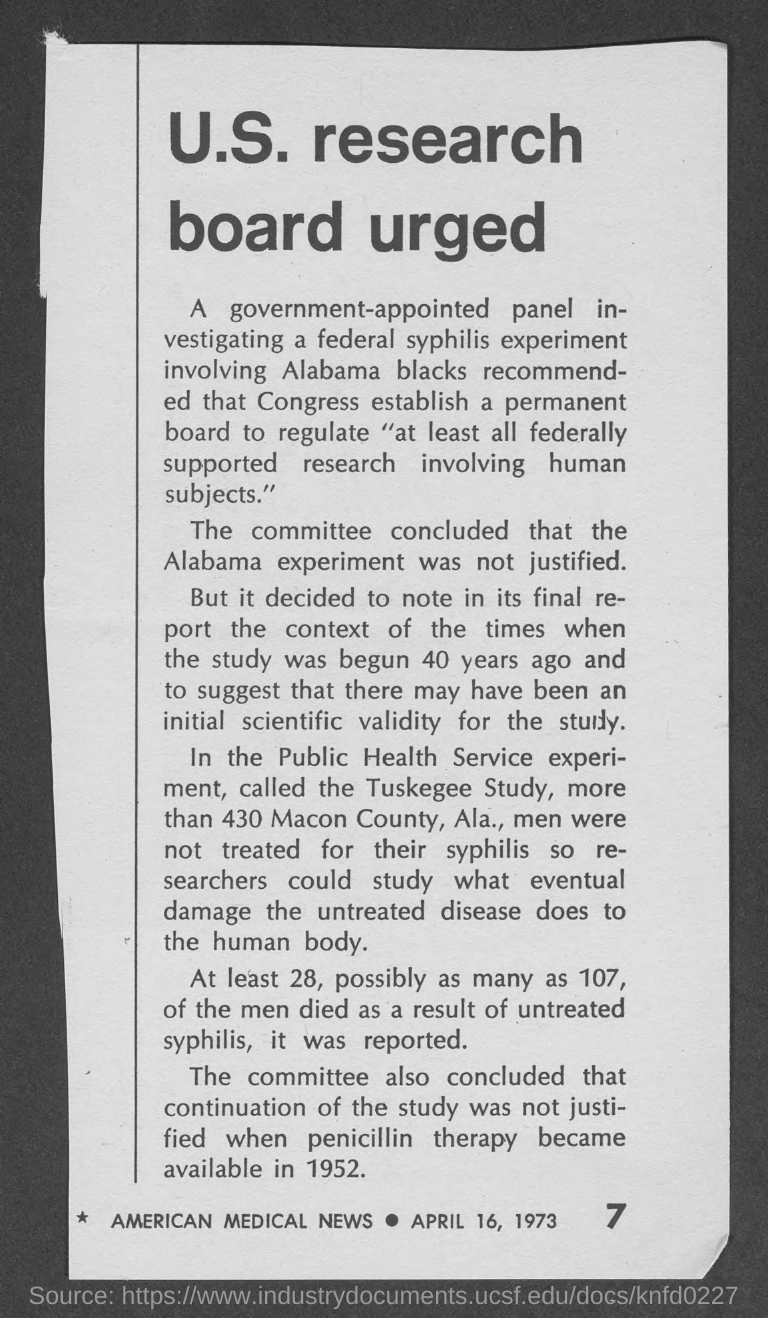Specify some key components in this picture. Penicillin therapy became available in 1952. The document in question has a date of April 16, 1973. 